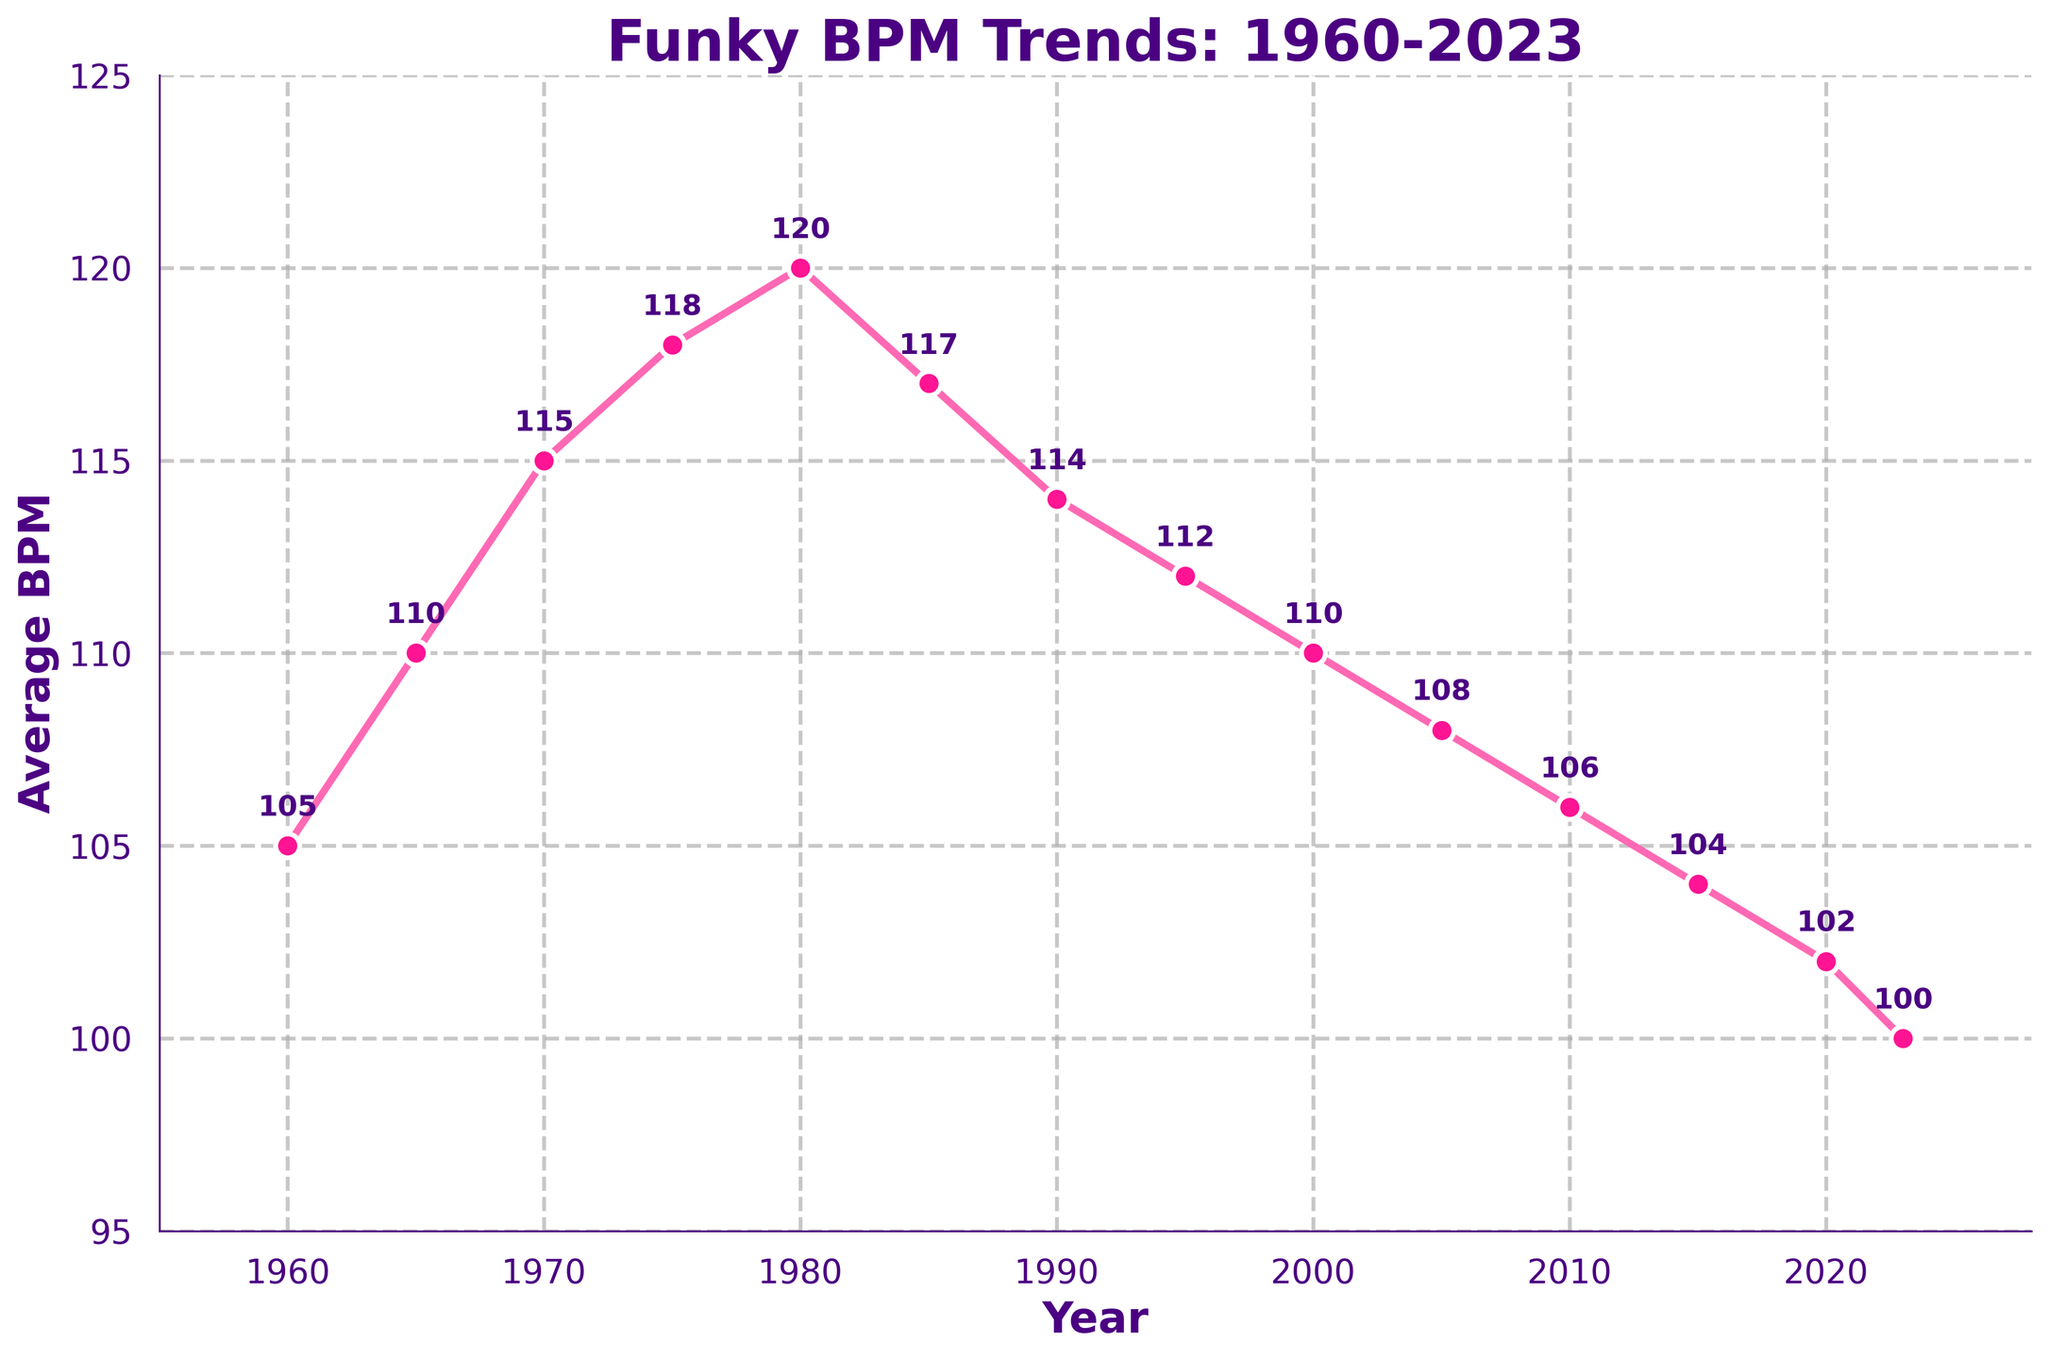What is the average BPM in 1985? To find the average BPM in 1985, locate the data point at 1985 on the x-axis and read the corresponding value on the y-axis, which is 117.
Answer: 117 Which year had the highest average BPM? Identify the peak point on the y-axis and trace it back to the x-axis. The highest point corresponds to the year 1980 with a BPM of 120.
Answer: 1980 How has the average BPM changed from 1960 to 2023? Compare the BPM values at 1960 (105) and 2023 (100). The BPM has decreased by 5 beats over this period.
Answer: Decreased by 5 Between which years did the BPM experience the steepest increase? Observe the slope of the line segments to identify the steepest. The increase from 1965 (110) to 1970 (115) represents the steepest climb of 5 BPM over 5 years.
Answer: 1965-1970 By how much did the average BPM decline from 1980 to 2023? Compare the average BPM in 1980 (120) to that in 2023 (100). The BPM declined by 20 beats.
Answer: Declined by 20 What was the average BPM in the year 2005? Locate the year 2005 on the x-axis and read the corresponding BPM value on the y-axis, which is 108.
Answer: 108 Which years have an average BPM lower than 105? Identify the data points below 105 BPM. They occur in 2015 (104), 2020 (102), and 2023 (100).
Answer: 2015, 2020, 2023 Compare the BPM in 1975 and 1990. Which year had a higher BPM and by how much? The BPM in 1975 is 118 and in 1990 is 114. 1975 had a higher BPM by 4 beats.
Answer: 1975 by 4 What is the average of the BPM values in 1960, 1970, and 1980? Sum the BPM values in 1960 (105), 1970 (115), and 1980 (120) to get 340. Divide by 3 to find the average: 340 / 3 = 113.33.
Answer: 113.33 Which two consecutive decades show a continuous decrease in BPM? Observe the plot and note the periods of continuous decline. From 1980 (120) to 2000 (110), the BPM decreases consistently.
Answer: 1980-1990 and 1990-2000 